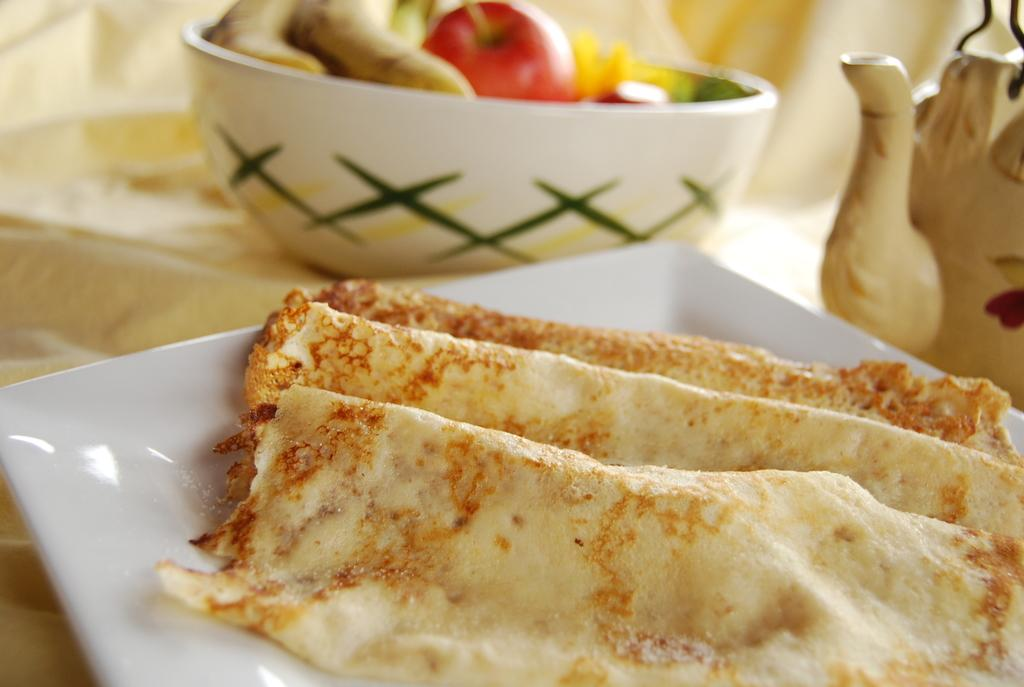What is on the plate in the image? There is food in a plate in the image. What else can be seen in the image besides the food? There is a teapot and fruits in a bowl in the image. Where are the food, teapot, and fruits placed in the image? They are placed on a surface. What type of birthday celebration is taking place in the image? There is no indication of a birthday celebration in the image. Where is the stage located in the image? There is no stage present in the image. 